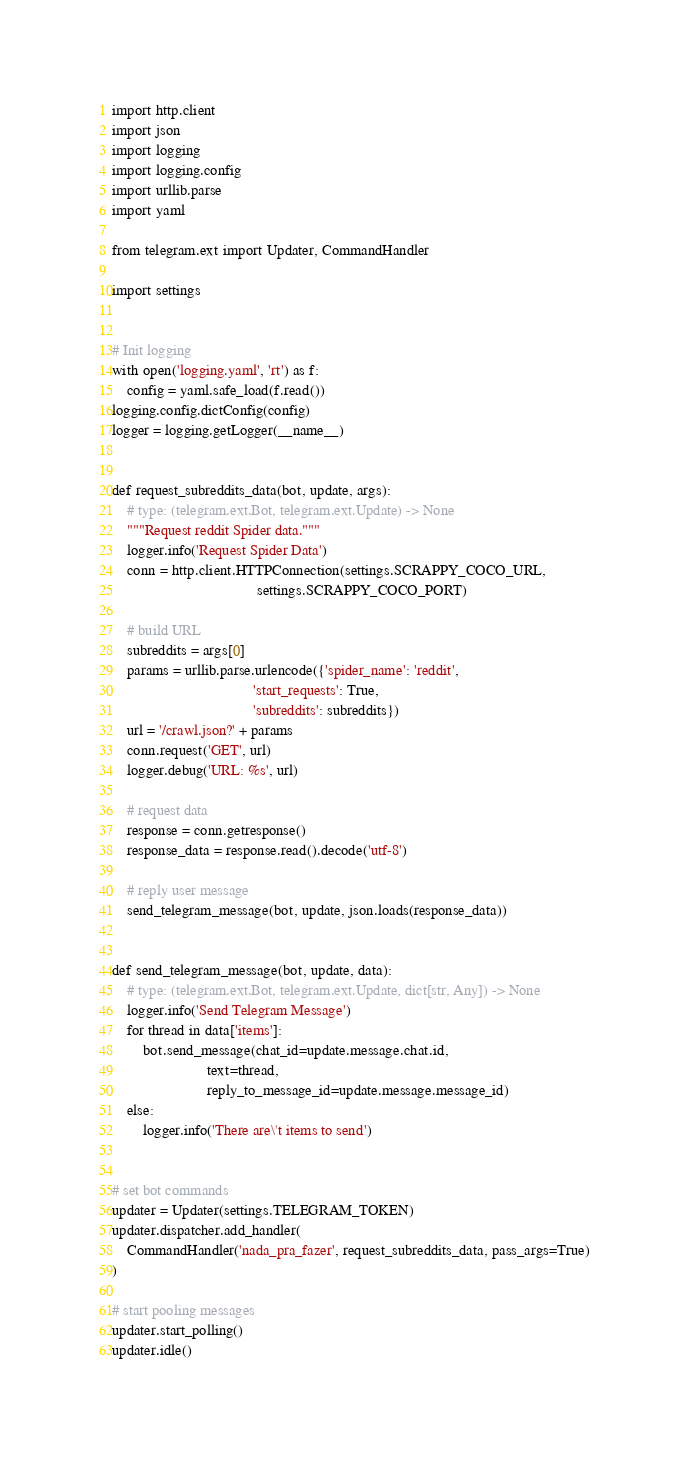<code> <loc_0><loc_0><loc_500><loc_500><_Python_>import http.client
import json
import logging
import logging.config
import urllib.parse
import yaml

from telegram.ext import Updater, CommandHandler

import settings


# Init logging
with open('logging.yaml', 'rt') as f:
    config = yaml.safe_load(f.read())
logging.config.dictConfig(config)
logger = logging.getLogger(__name__)


def request_subreddits_data(bot, update, args):
    # type: (telegram.ext.Bot, telegram.ext.Update) -> None
    """Request reddit Spider data."""
    logger.info('Request Spider Data')
    conn = http.client.HTTPConnection(settings.SCRAPPY_COCO_URL,
                                      settings.SCRAPPY_COCO_PORT)

    # build URL
    subreddits = args[0]
    params = urllib.parse.urlencode({'spider_name': 'reddit',
                                     'start_requests': True,
                                     'subreddits': subreddits})
    url = '/crawl.json?' + params
    conn.request('GET', url)
    logger.debug('URL: %s', url)

    # request data
    response = conn.getresponse()
    response_data = response.read().decode('utf-8')

    # reply user message
    send_telegram_message(bot, update, json.loads(response_data))


def send_telegram_message(bot, update, data):
    # type: (telegram.ext.Bot, telegram.ext.Update, dict[str, Any]) -> None
    logger.info('Send Telegram Message')
    for thread in data['items']:
        bot.send_message(chat_id=update.message.chat.id,
                         text=thread,
                         reply_to_message_id=update.message.message_id)
    else:
        logger.info('There are\'t items to send')


# set bot commands
updater = Updater(settings.TELEGRAM_TOKEN)
updater.dispatcher.add_handler(
    CommandHandler('nada_pra_fazer', request_subreddits_data, pass_args=True)
)

# start pooling messages
updater.start_polling()
updater.idle()
</code> 